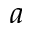Convert formula to latex. <formula><loc_0><loc_0><loc_500><loc_500>a</formula> 